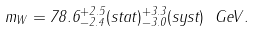<formula> <loc_0><loc_0><loc_500><loc_500>m _ { W } = 7 8 . 6 _ { - 2 . 4 } ^ { + 2 . 5 } ( s t a t ) _ { - 3 . 0 } ^ { + 3 . 3 } ( s y s t ) \ G e V .</formula> 